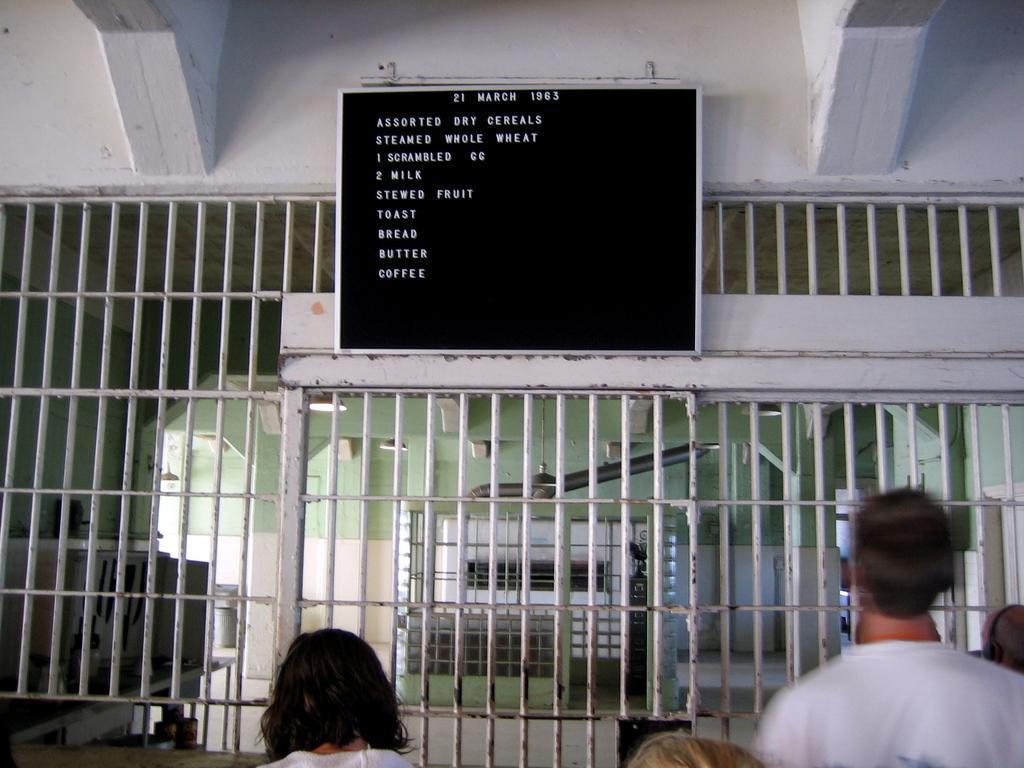Could you give a brief overview of what you see in this image? In the picture we can see a cage gate which is white in color and near it we can see some people are standing and on the top of it we can see a board with some menu like egg, milk, toast, bread, butter, coffee, and from the gate we can see a generator object to the ceiling. 